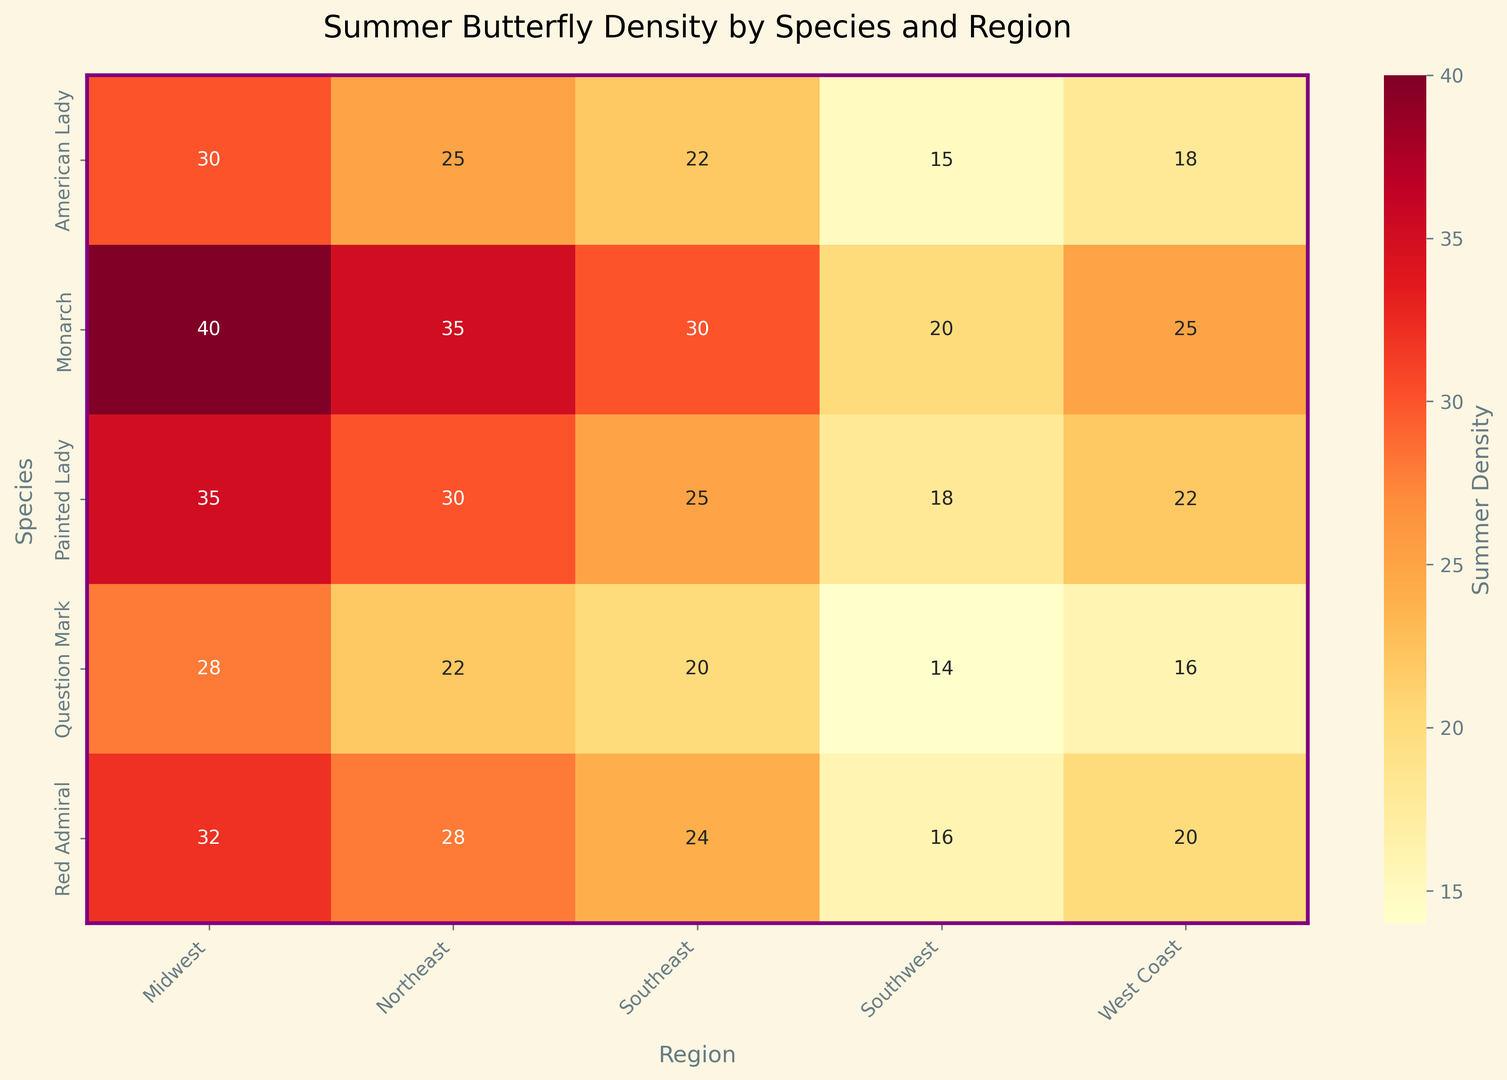Which region has the highest summer butterfly density for Monarch species? Look at the row corresponding to Monarch and find the maximum value in the summer density column. The highest value is 40 in the Midwest region.
Answer: Midwest Which species has the lowest summer butterfly density in the Southwest region? Check the Southwest column and find the species with the lowest summer value. The lowest value is 14, corresponding to the Question Mark species.
Answer: Question Mark What is the sum of the summer butterfly densities of the Painted Lady species across all regions? Sum the summer densities for the Painted Lady species across all regions: 30 (Northeast) + 35 (Midwest) + 25 (Southeast) + 18 (Southwest) + 22 (West Coast) = 130
Answer: 130 How does the summer density of Red Admiral in the West Coast compare to the Southeast? Compare the values in the West Coast and Southeast columns for Red Admiral. West Coast is 20, Southeast is 24. West Coast is less than Southeast.
Answer: Less Which species has the most uniform summer density across all regions? The species with the least variation in summer densities across regions is the most uniform. Painted Lady has values (30, 35, 25, 18, 22) which are more uniform compared to other species.
Answer: Painted Lady What's the average summer butterfly density for the American Lady species? Calculate the average by summing the summer densities of American Lady and dividing by the number of regions: (25 + 30 + 22 + 15 + 18)/5 = 22
Answer: 22 Is there any species whose summer density is highest in the same region as the Monarch in Northeast? Locate the species with the highest summer density in the Northeast region. Monarch has 35 in the Northeast, and no other species shares this top value in the Northeast.
Answer: No Which region shows the most significant variation in summer density across species? Measure the range (max-min) for each region. Southwest has the highest range of (20 to 16 = 4).
Answer: Southwest 